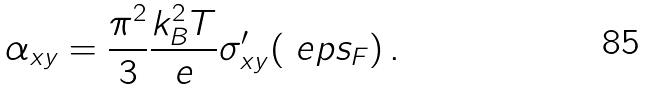<formula> <loc_0><loc_0><loc_500><loc_500>\alpha _ { x y } = \frac { \pi ^ { 2 } } { 3 } \frac { k _ { B } ^ { 2 } T } { e } \sigma ^ { \prime } _ { x y } ( \ e p s _ { F } ) \, .</formula> 